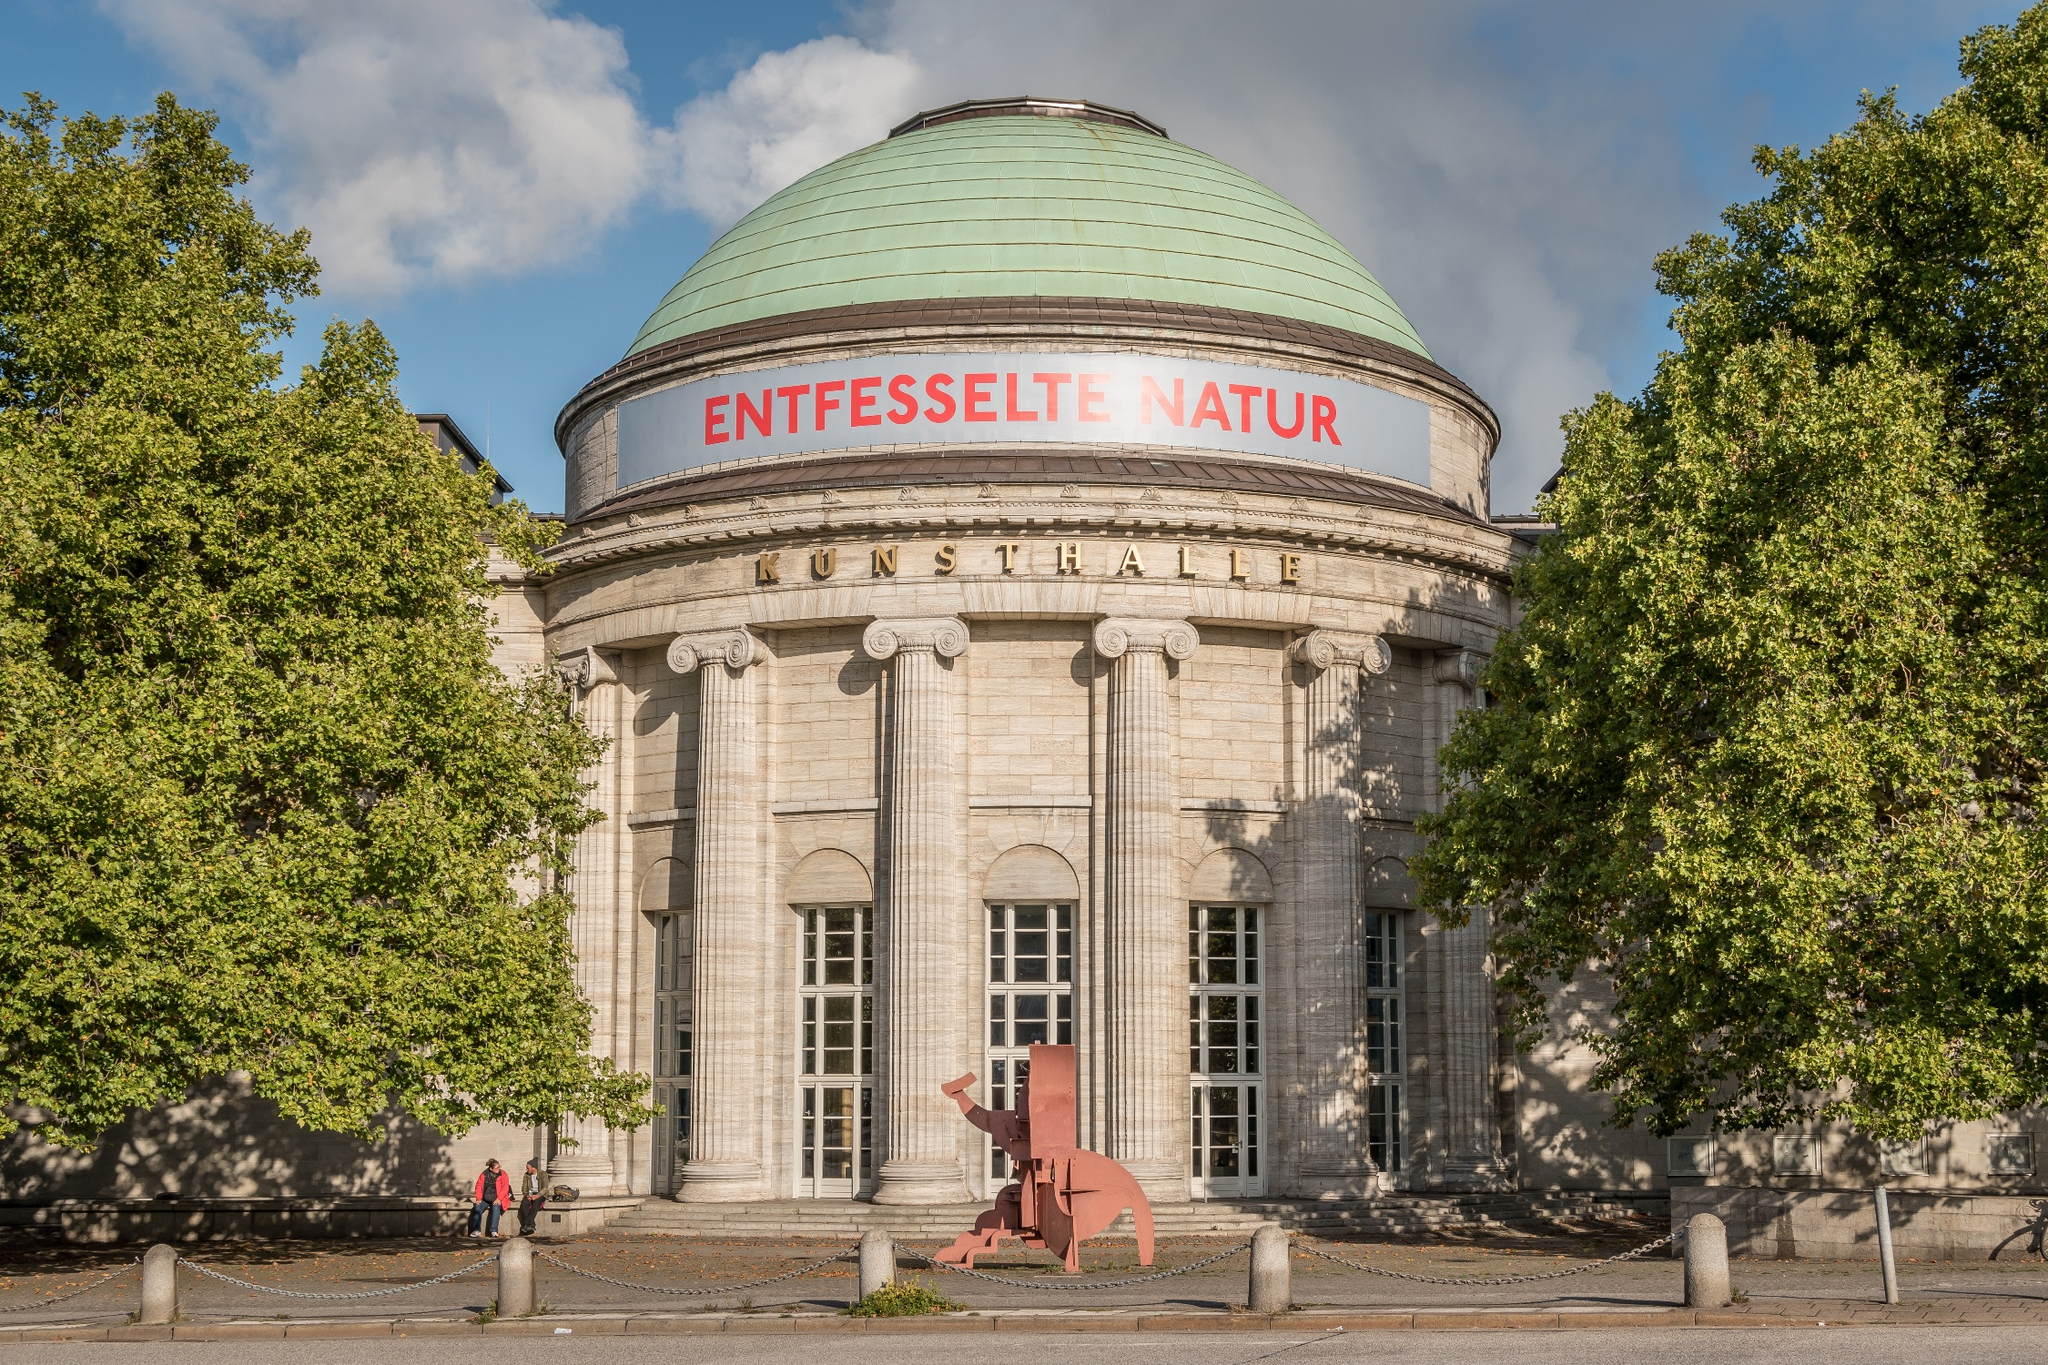Can you describe the architectural style of the building? The building in the image showcases a stunning neoclassical architectural style. This is evidenced by the use of large, impressive columns that support a grand dome. The dome itself is clad in a green patina, adding an element of aged elegance. The structure’s symmetrical design, coupled with its clean lines and classical detailing, exemplifies the grandeur and timelessness of neoclassical architecture. The prominent use of stone and the stately appearance of the facade contribute to its majestic and dignified presence in the urban landscape. 